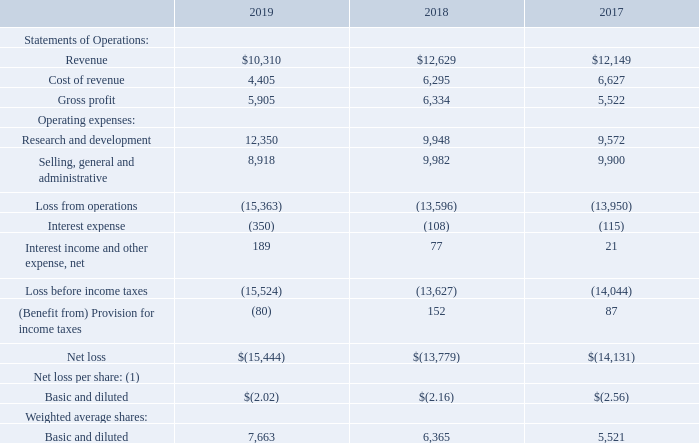Note: Net loss equals to comprehensive loss for all years presented.
(1) Net loss per share and weighted average shares, basic and diluted are adjusted to reflect 1-for-14 reverse stock split effected on December 23, 2019.
The accompanying notes form an integral part of these Consolidated Financial Statements.
CONSOLIDATED STATEMENTS OF OPERATIONS (in thousands, except per share amounts)
What are the respective revenue in 2018 and 2019?
Answer scale should be: thousand. $12,629, $10,310. What are the respective cost of revenue in 2018 and 2019?
Answer scale should be: thousand. 6,295, 4,405. What are the respective gross profit in 2018 and 2019?
Answer scale should be: thousand. 6,334, 5,905. What is the percentage change in revenue between 2018 and 2019?
Answer scale should be: percent. (10,310 - 12,629)/12,629 
Answer: -18.36. What is the percentage change in cost of revenue between 2018 and 2019?
Answer scale should be: percent. (4,405 - 6,295)/6,295 
Answer: -30.02. What is the percentage change in gross profit between 2018 and 2019?
Answer scale should be: percent. (5,905 - 6,334)/6,334 
Answer: -6.77. 